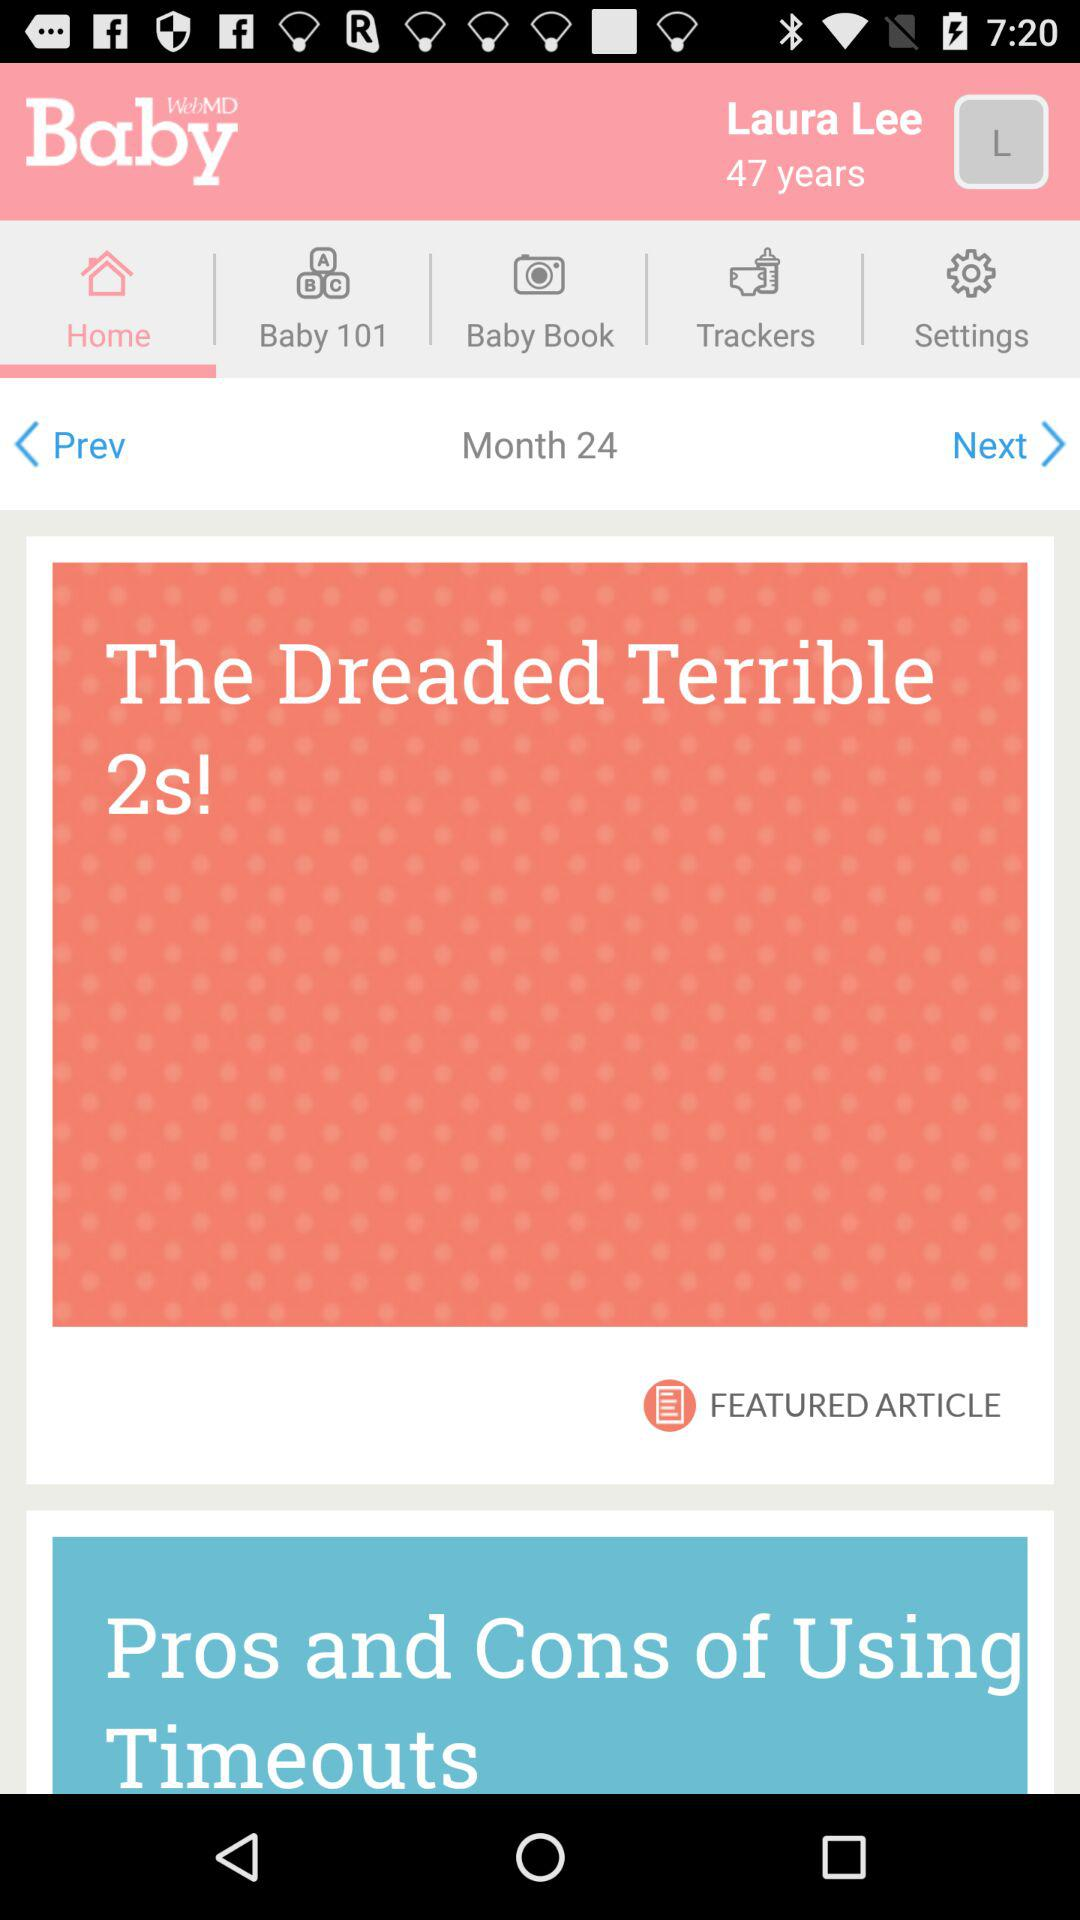What's the age of the person? The person is 47 years old. 